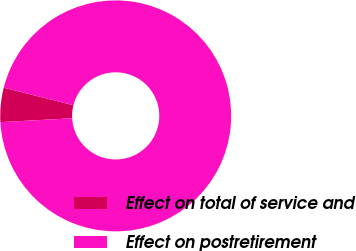<chart> <loc_0><loc_0><loc_500><loc_500><pie_chart><fcel>Effect on total of service and<fcel>Effect on postretirement<nl><fcel>4.79%<fcel>95.21%<nl></chart> 